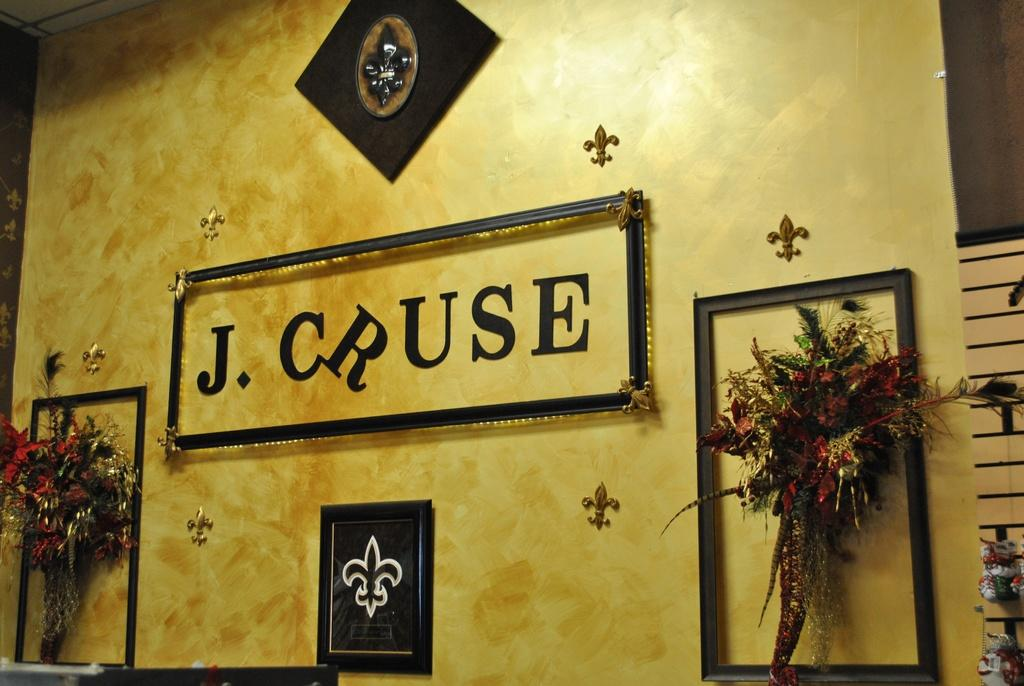How many boutiques can be seen in the image? There are two boutiques in the image. What is the relationship between the boutiques and the wall? The boutiques are attached to a wall. What colors are the flowers on the boutiques? The flowers on the boutiques are in red and green colors. What is attached to the wall in the image besides the boutiques? There is a frame attached to the wall in the image. What color is the wall in the image? The wall is in yellow color. How many potatoes are visible in the image? There are no potatoes present in the image. What type of coat is hanging on the wall in the image? There is no coat present in the image. 